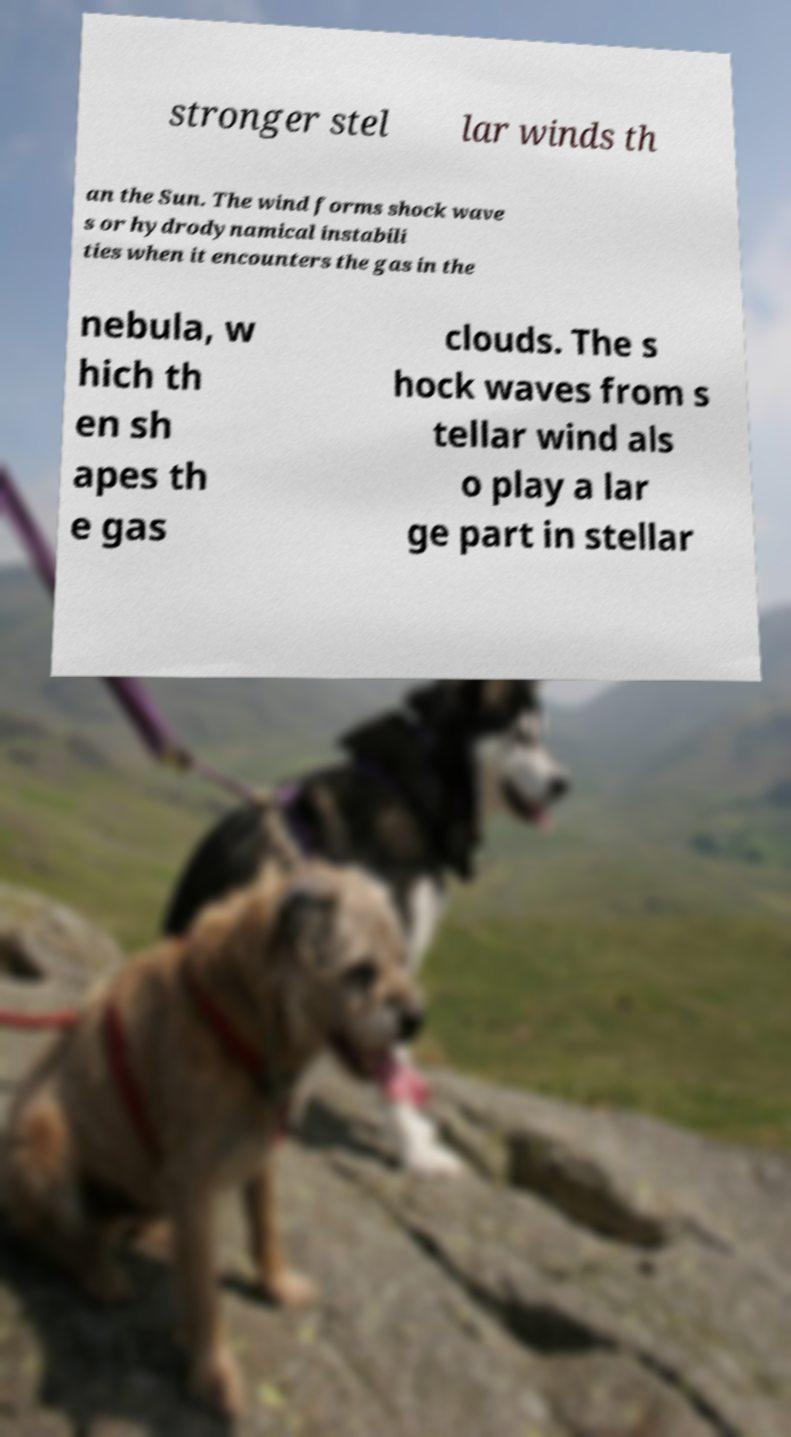There's text embedded in this image that I need extracted. Can you transcribe it verbatim? stronger stel lar winds th an the Sun. The wind forms shock wave s or hydrodynamical instabili ties when it encounters the gas in the nebula, w hich th en sh apes th e gas clouds. The s hock waves from s tellar wind als o play a lar ge part in stellar 